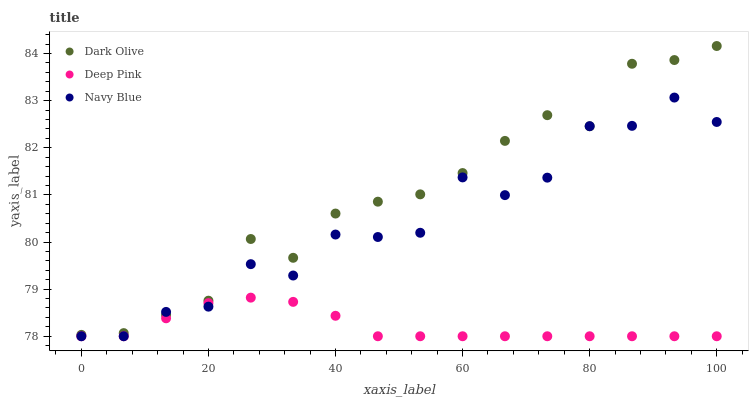Does Deep Pink have the minimum area under the curve?
Answer yes or no. Yes. Does Dark Olive have the maximum area under the curve?
Answer yes or no. Yes. Does Dark Olive have the minimum area under the curve?
Answer yes or no. No. Does Deep Pink have the maximum area under the curve?
Answer yes or no. No. Is Deep Pink the smoothest?
Answer yes or no. Yes. Is Navy Blue the roughest?
Answer yes or no. Yes. Is Dark Olive the smoothest?
Answer yes or no. No. Is Dark Olive the roughest?
Answer yes or no. No. Does Navy Blue have the lowest value?
Answer yes or no. Yes. Does Dark Olive have the lowest value?
Answer yes or no. No. Does Dark Olive have the highest value?
Answer yes or no. Yes. Does Deep Pink have the highest value?
Answer yes or no. No. Is Deep Pink less than Dark Olive?
Answer yes or no. Yes. Is Dark Olive greater than Deep Pink?
Answer yes or no. Yes. Does Navy Blue intersect Deep Pink?
Answer yes or no. Yes. Is Navy Blue less than Deep Pink?
Answer yes or no. No. Is Navy Blue greater than Deep Pink?
Answer yes or no. No. Does Deep Pink intersect Dark Olive?
Answer yes or no. No. 